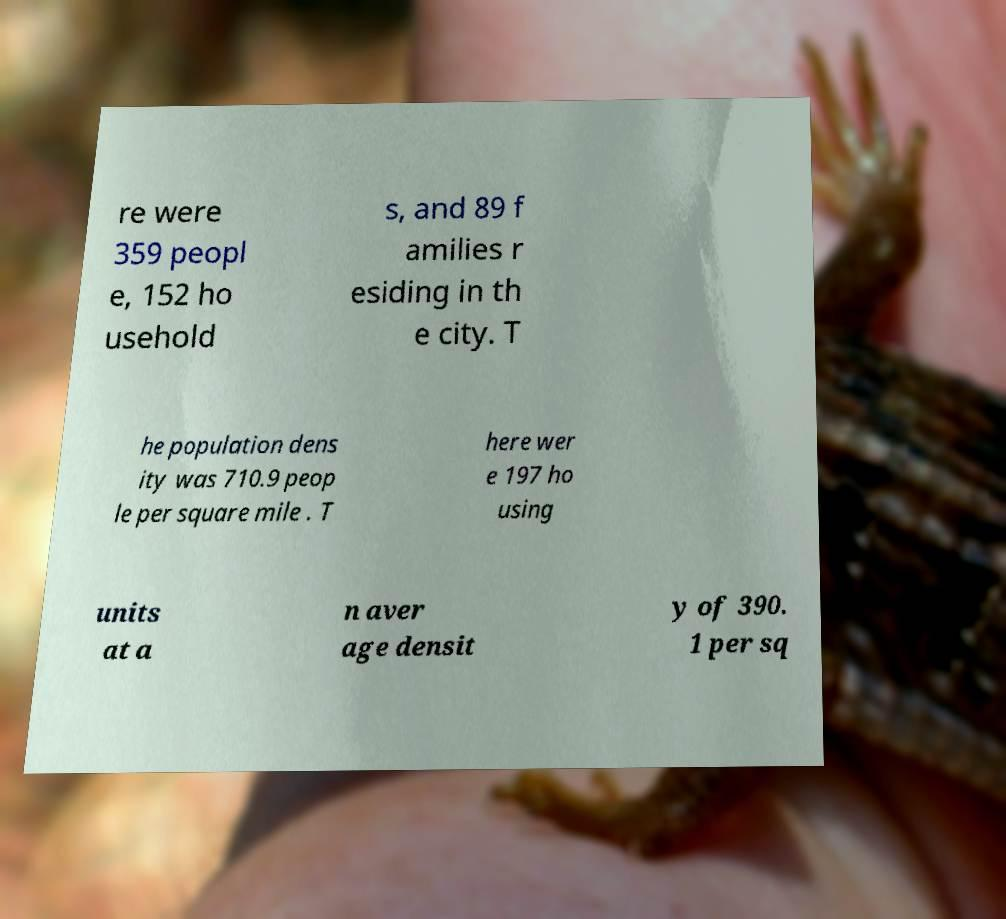Please identify and transcribe the text found in this image. re were 359 peopl e, 152 ho usehold s, and 89 f amilies r esiding in th e city. T he population dens ity was 710.9 peop le per square mile . T here wer e 197 ho using units at a n aver age densit y of 390. 1 per sq 